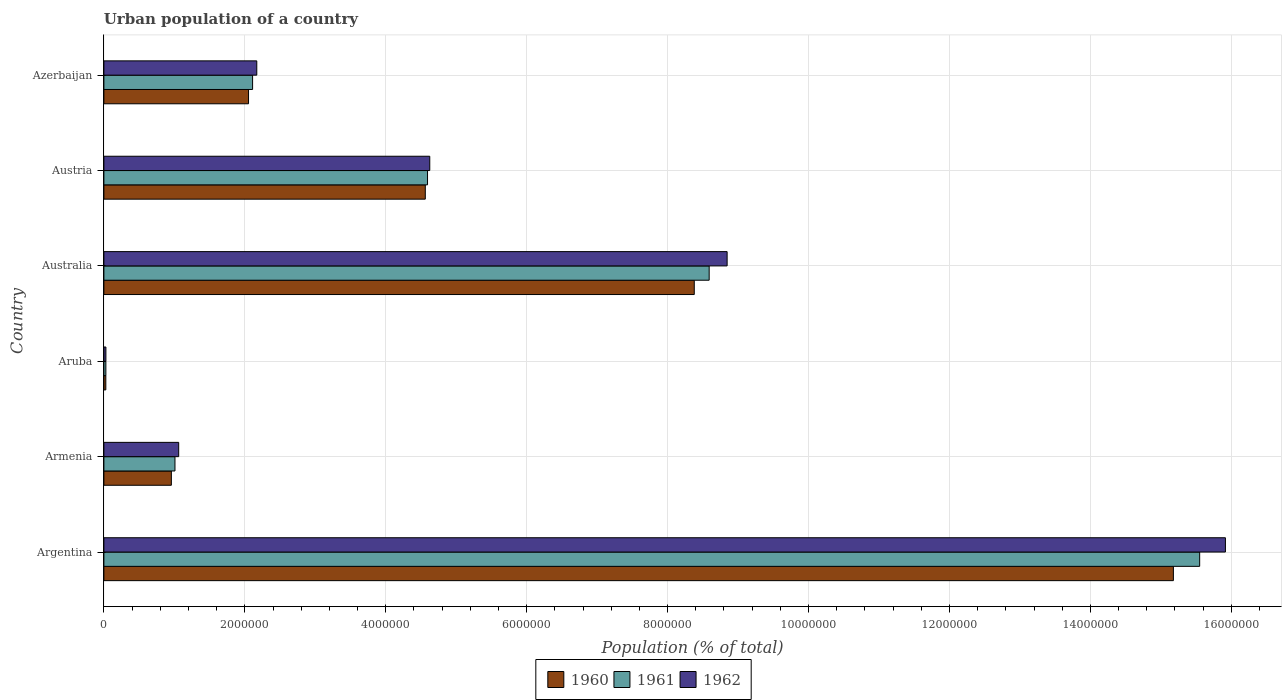How many groups of bars are there?
Provide a succinct answer. 6. Are the number of bars on each tick of the Y-axis equal?
Offer a very short reply. Yes. How many bars are there on the 1st tick from the top?
Ensure brevity in your answer.  3. What is the label of the 6th group of bars from the top?
Your answer should be compact. Argentina. What is the urban population in 1962 in Armenia?
Make the answer very short. 1.06e+06. Across all countries, what is the maximum urban population in 1961?
Provide a succinct answer. 1.56e+07. Across all countries, what is the minimum urban population in 1962?
Offer a terse response. 2.85e+04. In which country was the urban population in 1962 maximum?
Make the answer very short. Argentina. In which country was the urban population in 1961 minimum?
Your answer should be very brief. Aruba. What is the total urban population in 1960 in the graph?
Give a very brief answer. 3.12e+07. What is the difference between the urban population in 1961 in Australia and that in Azerbaijan?
Give a very brief answer. 6.48e+06. What is the difference between the urban population in 1962 in Aruba and the urban population in 1961 in Australia?
Offer a terse response. -8.56e+06. What is the average urban population in 1962 per country?
Your response must be concise. 5.44e+06. What is the difference between the urban population in 1961 and urban population in 1962 in Aruba?
Make the answer very short. -393. What is the ratio of the urban population in 1962 in Argentina to that in Australia?
Ensure brevity in your answer.  1.8. Is the urban population in 1962 in Aruba less than that in Azerbaijan?
Your answer should be compact. Yes. What is the difference between the highest and the second highest urban population in 1961?
Make the answer very short. 6.96e+06. What is the difference between the highest and the lowest urban population in 1961?
Provide a short and direct response. 1.55e+07. In how many countries, is the urban population in 1962 greater than the average urban population in 1962 taken over all countries?
Make the answer very short. 2. What does the 1st bar from the top in Aruba represents?
Make the answer very short. 1962. Is it the case that in every country, the sum of the urban population in 1960 and urban population in 1961 is greater than the urban population in 1962?
Ensure brevity in your answer.  Yes. How many countries are there in the graph?
Provide a short and direct response. 6. What is the difference between two consecutive major ticks on the X-axis?
Offer a very short reply. 2.00e+06. Where does the legend appear in the graph?
Your response must be concise. Bottom center. How many legend labels are there?
Offer a terse response. 3. What is the title of the graph?
Your response must be concise. Urban population of a country. Does "1962" appear as one of the legend labels in the graph?
Make the answer very short. Yes. What is the label or title of the X-axis?
Offer a terse response. Population (% of total). What is the Population (% of total) in 1960 in Argentina?
Provide a succinct answer. 1.52e+07. What is the Population (% of total) in 1961 in Argentina?
Ensure brevity in your answer.  1.56e+07. What is the Population (% of total) in 1962 in Argentina?
Your answer should be very brief. 1.59e+07. What is the Population (% of total) of 1960 in Armenia?
Your answer should be very brief. 9.58e+05. What is the Population (% of total) in 1961 in Armenia?
Your answer should be very brief. 1.01e+06. What is the Population (% of total) of 1962 in Armenia?
Offer a terse response. 1.06e+06. What is the Population (% of total) of 1960 in Aruba?
Give a very brief answer. 2.75e+04. What is the Population (% of total) of 1961 in Aruba?
Keep it short and to the point. 2.81e+04. What is the Population (% of total) of 1962 in Aruba?
Your answer should be very brief. 2.85e+04. What is the Population (% of total) in 1960 in Australia?
Make the answer very short. 8.38e+06. What is the Population (% of total) of 1961 in Australia?
Your response must be concise. 8.59e+06. What is the Population (% of total) of 1962 in Australia?
Provide a short and direct response. 8.84e+06. What is the Population (% of total) in 1960 in Austria?
Keep it short and to the point. 4.56e+06. What is the Population (% of total) of 1961 in Austria?
Your answer should be very brief. 4.59e+06. What is the Population (% of total) of 1962 in Austria?
Give a very brief answer. 4.62e+06. What is the Population (% of total) in 1960 in Azerbaijan?
Your answer should be very brief. 2.05e+06. What is the Population (% of total) in 1961 in Azerbaijan?
Keep it short and to the point. 2.11e+06. What is the Population (% of total) of 1962 in Azerbaijan?
Offer a very short reply. 2.17e+06. Across all countries, what is the maximum Population (% of total) of 1960?
Your response must be concise. 1.52e+07. Across all countries, what is the maximum Population (% of total) in 1961?
Ensure brevity in your answer.  1.56e+07. Across all countries, what is the maximum Population (% of total) in 1962?
Keep it short and to the point. 1.59e+07. Across all countries, what is the minimum Population (% of total) in 1960?
Your answer should be compact. 2.75e+04. Across all countries, what is the minimum Population (% of total) of 1961?
Make the answer very short. 2.81e+04. Across all countries, what is the minimum Population (% of total) in 1962?
Your response must be concise. 2.85e+04. What is the total Population (% of total) of 1960 in the graph?
Offer a terse response. 3.12e+07. What is the total Population (% of total) of 1961 in the graph?
Ensure brevity in your answer.  3.19e+07. What is the total Population (% of total) in 1962 in the graph?
Provide a succinct answer. 3.26e+07. What is the difference between the Population (% of total) of 1960 in Argentina and that in Armenia?
Your response must be concise. 1.42e+07. What is the difference between the Population (% of total) of 1961 in Argentina and that in Armenia?
Your response must be concise. 1.45e+07. What is the difference between the Population (% of total) of 1962 in Argentina and that in Armenia?
Offer a terse response. 1.49e+07. What is the difference between the Population (% of total) in 1960 in Argentina and that in Aruba?
Provide a short and direct response. 1.52e+07. What is the difference between the Population (% of total) in 1961 in Argentina and that in Aruba?
Make the answer very short. 1.55e+07. What is the difference between the Population (% of total) of 1962 in Argentina and that in Aruba?
Your response must be concise. 1.59e+07. What is the difference between the Population (% of total) in 1960 in Argentina and that in Australia?
Your answer should be very brief. 6.80e+06. What is the difference between the Population (% of total) in 1961 in Argentina and that in Australia?
Keep it short and to the point. 6.96e+06. What is the difference between the Population (% of total) in 1962 in Argentina and that in Australia?
Offer a very short reply. 7.07e+06. What is the difference between the Population (% of total) of 1960 in Argentina and that in Austria?
Provide a succinct answer. 1.06e+07. What is the difference between the Population (% of total) in 1961 in Argentina and that in Austria?
Offer a terse response. 1.10e+07. What is the difference between the Population (% of total) of 1962 in Argentina and that in Austria?
Provide a short and direct response. 1.13e+07. What is the difference between the Population (% of total) in 1960 in Argentina and that in Azerbaijan?
Your answer should be very brief. 1.31e+07. What is the difference between the Population (% of total) in 1961 in Argentina and that in Azerbaijan?
Your response must be concise. 1.34e+07. What is the difference between the Population (% of total) in 1962 in Argentina and that in Azerbaijan?
Provide a short and direct response. 1.37e+07. What is the difference between the Population (% of total) of 1960 in Armenia and that in Aruba?
Ensure brevity in your answer.  9.30e+05. What is the difference between the Population (% of total) in 1961 in Armenia and that in Aruba?
Make the answer very short. 9.81e+05. What is the difference between the Population (% of total) of 1962 in Armenia and that in Aruba?
Ensure brevity in your answer.  1.03e+06. What is the difference between the Population (% of total) of 1960 in Armenia and that in Australia?
Ensure brevity in your answer.  -7.42e+06. What is the difference between the Population (% of total) in 1961 in Armenia and that in Australia?
Your answer should be very brief. -7.58e+06. What is the difference between the Population (% of total) of 1962 in Armenia and that in Australia?
Make the answer very short. -7.78e+06. What is the difference between the Population (% of total) in 1960 in Armenia and that in Austria?
Offer a terse response. -3.60e+06. What is the difference between the Population (% of total) in 1961 in Armenia and that in Austria?
Your answer should be very brief. -3.58e+06. What is the difference between the Population (% of total) in 1962 in Armenia and that in Austria?
Provide a succinct answer. -3.56e+06. What is the difference between the Population (% of total) of 1960 in Armenia and that in Azerbaijan?
Make the answer very short. -1.10e+06. What is the difference between the Population (% of total) of 1961 in Armenia and that in Azerbaijan?
Keep it short and to the point. -1.10e+06. What is the difference between the Population (% of total) of 1962 in Armenia and that in Azerbaijan?
Your answer should be compact. -1.11e+06. What is the difference between the Population (% of total) of 1960 in Aruba and that in Australia?
Your answer should be compact. -8.35e+06. What is the difference between the Population (% of total) in 1961 in Aruba and that in Australia?
Your response must be concise. -8.56e+06. What is the difference between the Population (% of total) in 1962 in Aruba and that in Australia?
Give a very brief answer. -8.82e+06. What is the difference between the Population (% of total) in 1960 in Aruba and that in Austria?
Provide a short and direct response. -4.53e+06. What is the difference between the Population (% of total) in 1961 in Aruba and that in Austria?
Provide a short and direct response. -4.56e+06. What is the difference between the Population (% of total) of 1962 in Aruba and that in Austria?
Your response must be concise. -4.60e+06. What is the difference between the Population (% of total) in 1960 in Aruba and that in Azerbaijan?
Your answer should be very brief. -2.03e+06. What is the difference between the Population (% of total) of 1961 in Aruba and that in Azerbaijan?
Your answer should be compact. -2.08e+06. What is the difference between the Population (% of total) in 1962 in Aruba and that in Azerbaijan?
Provide a short and direct response. -2.14e+06. What is the difference between the Population (% of total) in 1960 in Australia and that in Austria?
Your response must be concise. 3.82e+06. What is the difference between the Population (% of total) of 1961 in Australia and that in Austria?
Keep it short and to the point. 4.00e+06. What is the difference between the Population (% of total) of 1962 in Australia and that in Austria?
Your answer should be very brief. 4.22e+06. What is the difference between the Population (% of total) in 1960 in Australia and that in Azerbaijan?
Offer a very short reply. 6.33e+06. What is the difference between the Population (% of total) of 1961 in Australia and that in Azerbaijan?
Your answer should be very brief. 6.48e+06. What is the difference between the Population (% of total) in 1962 in Australia and that in Azerbaijan?
Your answer should be very brief. 6.67e+06. What is the difference between the Population (% of total) in 1960 in Austria and that in Azerbaijan?
Your answer should be compact. 2.51e+06. What is the difference between the Population (% of total) of 1961 in Austria and that in Azerbaijan?
Your answer should be very brief. 2.48e+06. What is the difference between the Population (% of total) in 1962 in Austria and that in Azerbaijan?
Provide a short and direct response. 2.45e+06. What is the difference between the Population (% of total) of 1960 in Argentina and the Population (% of total) of 1961 in Armenia?
Ensure brevity in your answer.  1.42e+07. What is the difference between the Population (% of total) of 1960 in Argentina and the Population (% of total) of 1962 in Armenia?
Make the answer very short. 1.41e+07. What is the difference between the Population (% of total) of 1961 in Argentina and the Population (% of total) of 1962 in Armenia?
Provide a short and direct response. 1.45e+07. What is the difference between the Population (% of total) in 1960 in Argentina and the Population (% of total) in 1961 in Aruba?
Offer a terse response. 1.51e+07. What is the difference between the Population (% of total) in 1960 in Argentina and the Population (% of total) in 1962 in Aruba?
Provide a short and direct response. 1.51e+07. What is the difference between the Population (% of total) of 1961 in Argentina and the Population (% of total) of 1962 in Aruba?
Your answer should be very brief. 1.55e+07. What is the difference between the Population (% of total) in 1960 in Argentina and the Population (% of total) in 1961 in Australia?
Give a very brief answer. 6.59e+06. What is the difference between the Population (% of total) in 1960 in Argentina and the Population (% of total) in 1962 in Australia?
Your response must be concise. 6.33e+06. What is the difference between the Population (% of total) in 1961 in Argentina and the Population (% of total) in 1962 in Australia?
Offer a very short reply. 6.71e+06. What is the difference between the Population (% of total) in 1960 in Argentina and the Population (% of total) in 1961 in Austria?
Provide a succinct answer. 1.06e+07. What is the difference between the Population (% of total) of 1960 in Argentina and the Population (% of total) of 1962 in Austria?
Provide a succinct answer. 1.06e+07. What is the difference between the Population (% of total) in 1961 in Argentina and the Population (% of total) in 1962 in Austria?
Offer a very short reply. 1.09e+07. What is the difference between the Population (% of total) of 1960 in Argentina and the Population (% of total) of 1961 in Azerbaijan?
Your answer should be very brief. 1.31e+07. What is the difference between the Population (% of total) in 1960 in Argentina and the Population (% of total) in 1962 in Azerbaijan?
Your answer should be compact. 1.30e+07. What is the difference between the Population (% of total) in 1961 in Argentina and the Population (% of total) in 1962 in Azerbaijan?
Your answer should be very brief. 1.34e+07. What is the difference between the Population (% of total) of 1960 in Armenia and the Population (% of total) of 1961 in Aruba?
Give a very brief answer. 9.29e+05. What is the difference between the Population (% of total) in 1960 in Armenia and the Population (% of total) in 1962 in Aruba?
Ensure brevity in your answer.  9.29e+05. What is the difference between the Population (% of total) of 1961 in Armenia and the Population (% of total) of 1962 in Aruba?
Offer a terse response. 9.80e+05. What is the difference between the Population (% of total) of 1960 in Armenia and the Population (% of total) of 1961 in Australia?
Your answer should be very brief. -7.63e+06. What is the difference between the Population (% of total) of 1960 in Armenia and the Population (% of total) of 1962 in Australia?
Offer a very short reply. -7.89e+06. What is the difference between the Population (% of total) in 1961 in Armenia and the Population (% of total) in 1962 in Australia?
Offer a terse response. -7.84e+06. What is the difference between the Population (% of total) of 1960 in Armenia and the Population (% of total) of 1961 in Austria?
Give a very brief answer. -3.64e+06. What is the difference between the Population (% of total) in 1960 in Armenia and the Population (% of total) in 1962 in Austria?
Provide a short and direct response. -3.67e+06. What is the difference between the Population (% of total) of 1961 in Armenia and the Population (% of total) of 1962 in Austria?
Your answer should be compact. -3.62e+06. What is the difference between the Population (% of total) in 1960 in Armenia and the Population (% of total) in 1961 in Azerbaijan?
Provide a succinct answer. -1.15e+06. What is the difference between the Population (% of total) of 1960 in Armenia and the Population (% of total) of 1962 in Azerbaijan?
Ensure brevity in your answer.  -1.21e+06. What is the difference between the Population (% of total) of 1961 in Armenia and the Population (% of total) of 1962 in Azerbaijan?
Keep it short and to the point. -1.16e+06. What is the difference between the Population (% of total) of 1960 in Aruba and the Population (% of total) of 1961 in Australia?
Your answer should be very brief. -8.56e+06. What is the difference between the Population (% of total) in 1960 in Aruba and the Population (% of total) in 1962 in Australia?
Your answer should be compact. -8.82e+06. What is the difference between the Population (% of total) of 1961 in Aruba and the Population (% of total) of 1962 in Australia?
Keep it short and to the point. -8.82e+06. What is the difference between the Population (% of total) in 1960 in Aruba and the Population (% of total) in 1961 in Austria?
Offer a very short reply. -4.57e+06. What is the difference between the Population (% of total) in 1960 in Aruba and the Population (% of total) in 1962 in Austria?
Offer a very short reply. -4.60e+06. What is the difference between the Population (% of total) in 1961 in Aruba and the Population (% of total) in 1962 in Austria?
Keep it short and to the point. -4.60e+06. What is the difference between the Population (% of total) in 1960 in Aruba and the Population (% of total) in 1961 in Azerbaijan?
Keep it short and to the point. -2.08e+06. What is the difference between the Population (% of total) of 1960 in Aruba and the Population (% of total) of 1962 in Azerbaijan?
Your answer should be compact. -2.14e+06. What is the difference between the Population (% of total) of 1961 in Aruba and the Population (% of total) of 1962 in Azerbaijan?
Provide a succinct answer. -2.14e+06. What is the difference between the Population (% of total) of 1960 in Australia and the Population (% of total) of 1961 in Austria?
Ensure brevity in your answer.  3.79e+06. What is the difference between the Population (% of total) of 1960 in Australia and the Population (% of total) of 1962 in Austria?
Provide a short and direct response. 3.75e+06. What is the difference between the Population (% of total) in 1961 in Australia and the Population (% of total) in 1962 in Austria?
Your response must be concise. 3.97e+06. What is the difference between the Population (% of total) of 1960 in Australia and the Population (% of total) of 1961 in Azerbaijan?
Make the answer very short. 6.27e+06. What is the difference between the Population (% of total) of 1960 in Australia and the Population (% of total) of 1962 in Azerbaijan?
Your answer should be compact. 6.21e+06. What is the difference between the Population (% of total) in 1961 in Australia and the Population (% of total) in 1962 in Azerbaijan?
Your response must be concise. 6.42e+06. What is the difference between the Population (% of total) of 1960 in Austria and the Population (% of total) of 1961 in Azerbaijan?
Your response must be concise. 2.45e+06. What is the difference between the Population (% of total) in 1960 in Austria and the Population (% of total) in 1962 in Azerbaijan?
Offer a terse response. 2.39e+06. What is the difference between the Population (% of total) of 1961 in Austria and the Population (% of total) of 1962 in Azerbaijan?
Make the answer very short. 2.42e+06. What is the average Population (% of total) of 1960 per country?
Your answer should be compact. 5.19e+06. What is the average Population (% of total) in 1961 per country?
Ensure brevity in your answer.  5.31e+06. What is the average Population (% of total) of 1962 per country?
Make the answer very short. 5.44e+06. What is the difference between the Population (% of total) of 1960 and Population (% of total) of 1961 in Argentina?
Keep it short and to the point. -3.73e+05. What is the difference between the Population (% of total) in 1960 and Population (% of total) in 1962 in Argentina?
Offer a terse response. -7.38e+05. What is the difference between the Population (% of total) in 1961 and Population (% of total) in 1962 in Argentina?
Give a very brief answer. -3.65e+05. What is the difference between the Population (% of total) in 1960 and Population (% of total) in 1961 in Armenia?
Your answer should be compact. -5.11e+04. What is the difference between the Population (% of total) in 1960 and Population (% of total) in 1962 in Armenia?
Your response must be concise. -1.04e+05. What is the difference between the Population (% of total) in 1961 and Population (% of total) in 1962 in Armenia?
Provide a succinct answer. -5.29e+04. What is the difference between the Population (% of total) in 1960 and Population (% of total) in 1961 in Aruba?
Your answer should be compact. -614. What is the difference between the Population (% of total) in 1960 and Population (% of total) in 1962 in Aruba?
Provide a succinct answer. -1007. What is the difference between the Population (% of total) in 1961 and Population (% of total) in 1962 in Aruba?
Offer a terse response. -393. What is the difference between the Population (% of total) of 1960 and Population (% of total) of 1961 in Australia?
Make the answer very short. -2.12e+05. What is the difference between the Population (% of total) of 1960 and Population (% of total) of 1962 in Australia?
Give a very brief answer. -4.66e+05. What is the difference between the Population (% of total) in 1961 and Population (% of total) in 1962 in Australia?
Your response must be concise. -2.55e+05. What is the difference between the Population (% of total) in 1960 and Population (% of total) in 1961 in Austria?
Keep it short and to the point. -3.17e+04. What is the difference between the Population (% of total) of 1960 and Population (% of total) of 1962 in Austria?
Keep it short and to the point. -6.35e+04. What is the difference between the Population (% of total) of 1961 and Population (% of total) of 1962 in Austria?
Keep it short and to the point. -3.17e+04. What is the difference between the Population (% of total) of 1960 and Population (% of total) of 1961 in Azerbaijan?
Give a very brief answer. -5.76e+04. What is the difference between the Population (% of total) in 1960 and Population (% of total) in 1962 in Azerbaijan?
Give a very brief answer. -1.17e+05. What is the difference between the Population (% of total) of 1961 and Population (% of total) of 1962 in Azerbaijan?
Make the answer very short. -5.95e+04. What is the ratio of the Population (% of total) in 1960 in Argentina to that in Armenia?
Your answer should be very brief. 15.85. What is the ratio of the Population (% of total) in 1961 in Argentina to that in Armenia?
Your response must be concise. 15.42. What is the ratio of the Population (% of total) in 1962 in Argentina to that in Armenia?
Keep it short and to the point. 14.99. What is the ratio of the Population (% of total) of 1960 in Argentina to that in Aruba?
Provide a short and direct response. 551.42. What is the ratio of the Population (% of total) of 1961 in Argentina to that in Aruba?
Make the answer very short. 552.64. What is the ratio of the Population (% of total) of 1962 in Argentina to that in Aruba?
Provide a succinct answer. 557.84. What is the ratio of the Population (% of total) in 1960 in Argentina to that in Australia?
Give a very brief answer. 1.81. What is the ratio of the Population (% of total) in 1961 in Argentina to that in Australia?
Give a very brief answer. 1.81. What is the ratio of the Population (% of total) in 1962 in Argentina to that in Australia?
Offer a very short reply. 1.8. What is the ratio of the Population (% of total) in 1960 in Argentina to that in Austria?
Offer a terse response. 3.33. What is the ratio of the Population (% of total) of 1961 in Argentina to that in Austria?
Offer a terse response. 3.39. What is the ratio of the Population (% of total) in 1962 in Argentina to that in Austria?
Keep it short and to the point. 3.44. What is the ratio of the Population (% of total) of 1960 in Argentina to that in Azerbaijan?
Provide a short and direct response. 7.39. What is the ratio of the Population (% of total) in 1961 in Argentina to that in Azerbaijan?
Your response must be concise. 7.37. What is the ratio of the Population (% of total) of 1962 in Argentina to that in Azerbaijan?
Your answer should be compact. 7.34. What is the ratio of the Population (% of total) of 1960 in Armenia to that in Aruba?
Give a very brief answer. 34.79. What is the ratio of the Population (% of total) in 1961 in Armenia to that in Aruba?
Your answer should be very brief. 35.85. What is the ratio of the Population (% of total) of 1962 in Armenia to that in Aruba?
Your answer should be compact. 37.2. What is the ratio of the Population (% of total) in 1960 in Armenia to that in Australia?
Keep it short and to the point. 0.11. What is the ratio of the Population (% of total) of 1961 in Armenia to that in Australia?
Ensure brevity in your answer.  0.12. What is the ratio of the Population (% of total) in 1962 in Armenia to that in Australia?
Make the answer very short. 0.12. What is the ratio of the Population (% of total) in 1960 in Armenia to that in Austria?
Ensure brevity in your answer.  0.21. What is the ratio of the Population (% of total) in 1961 in Armenia to that in Austria?
Offer a terse response. 0.22. What is the ratio of the Population (% of total) of 1962 in Armenia to that in Austria?
Your answer should be very brief. 0.23. What is the ratio of the Population (% of total) of 1960 in Armenia to that in Azerbaijan?
Give a very brief answer. 0.47. What is the ratio of the Population (% of total) of 1961 in Armenia to that in Azerbaijan?
Provide a succinct answer. 0.48. What is the ratio of the Population (% of total) of 1962 in Armenia to that in Azerbaijan?
Offer a very short reply. 0.49. What is the ratio of the Population (% of total) in 1960 in Aruba to that in Australia?
Offer a very short reply. 0. What is the ratio of the Population (% of total) of 1961 in Aruba to that in Australia?
Keep it short and to the point. 0. What is the ratio of the Population (% of total) of 1962 in Aruba to that in Australia?
Offer a terse response. 0. What is the ratio of the Population (% of total) in 1960 in Aruba to that in Austria?
Keep it short and to the point. 0.01. What is the ratio of the Population (% of total) of 1961 in Aruba to that in Austria?
Provide a short and direct response. 0.01. What is the ratio of the Population (% of total) in 1962 in Aruba to that in Austria?
Offer a very short reply. 0.01. What is the ratio of the Population (% of total) of 1960 in Aruba to that in Azerbaijan?
Provide a succinct answer. 0.01. What is the ratio of the Population (% of total) in 1961 in Aruba to that in Azerbaijan?
Your answer should be compact. 0.01. What is the ratio of the Population (% of total) of 1962 in Aruba to that in Azerbaijan?
Your answer should be compact. 0.01. What is the ratio of the Population (% of total) in 1960 in Australia to that in Austria?
Your answer should be compact. 1.84. What is the ratio of the Population (% of total) in 1961 in Australia to that in Austria?
Your answer should be very brief. 1.87. What is the ratio of the Population (% of total) in 1962 in Australia to that in Austria?
Ensure brevity in your answer.  1.91. What is the ratio of the Population (% of total) of 1960 in Australia to that in Azerbaijan?
Provide a succinct answer. 4.08. What is the ratio of the Population (% of total) in 1961 in Australia to that in Azerbaijan?
Offer a very short reply. 4.07. What is the ratio of the Population (% of total) in 1962 in Australia to that in Azerbaijan?
Your answer should be compact. 4.08. What is the ratio of the Population (% of total) of 1960 in Austria to that in Azerbaijan?
Keep it short and to the point. 2.22. What is the ratio of the Population (% of total) in 1961 in Austria to that in Azerbaijan?
Your answer should be very brief. 2.18. What is the ratio of the Population (% of total) in 1962 in Austria to that in Azerbaijan?
Give a very brief answer. 2.13. What is the difference between the highest and the second highest Population (% of total) in 1960?
Offer a very short reply. 6.80e+06. What is the difference between the highest and the second highest Population (% of total) of 1961?
Provide a succinct answer. 6.96e+06. What is the difference between the highest and the second highest Population (% of total) of 1962?
Your answer should be compact. 7.07e+06. What is the difference between the highest and the lowest Population (% of total) of 1960?
Ensure brevity in your answer.  1.52e+07. What is the difference between the highest and the lowest Population (% of total) in 1961?
Offer a very short reply. 1.55e+07. What is the difference between the highest and the lowest Population (% of total) of 1962?
Your answer should be compact. 1.59e+07. 